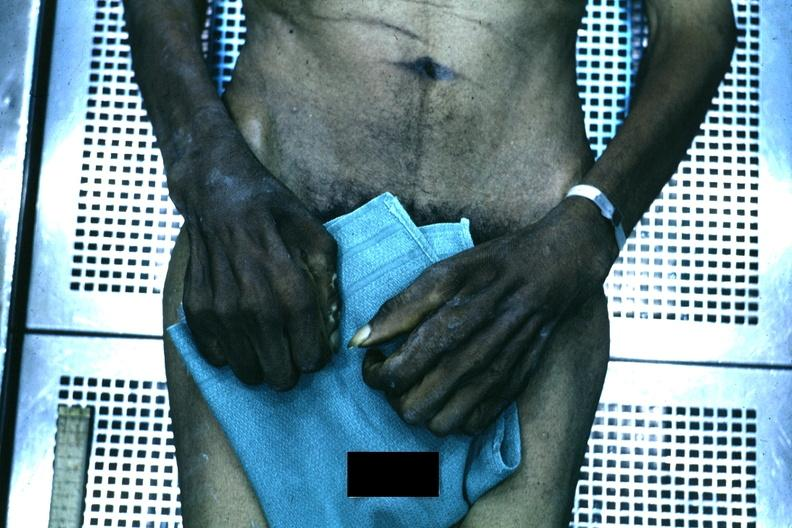does this image show good example of muscle atrophy said to be due to syringomyelia?
Answer the question using a single word or phrase. Yes 